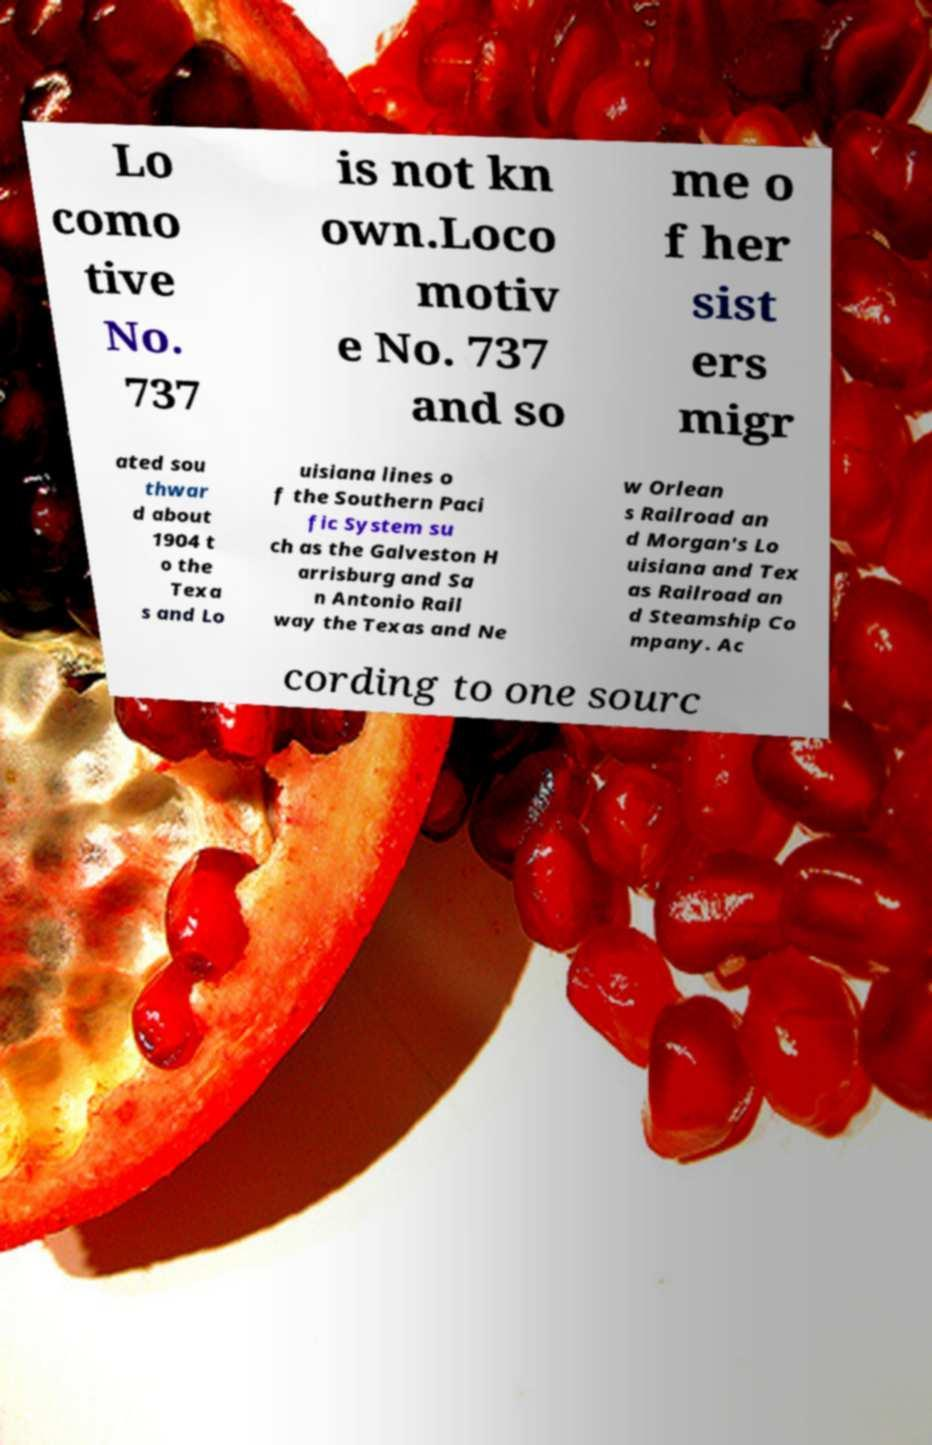For documentation purposes, I need the text within this image transcribed. Could you provide that? Lo como tive No. 737 is not kn own.Loco motiv e No. 737 and so me o f her sist ers migr ated sou thwar d about 1904 t o the Texa s and Lo uisiana lines o f the Southern Paci fic System su ch as the Galveston H arrisburg and Sa n Antonio Rail way the Texas and Ne w Orlean s Railroad an d Morgan's Lo uisiana and Tex as Railroad an d Steamship Co mpany. Ac cording to one sourc 